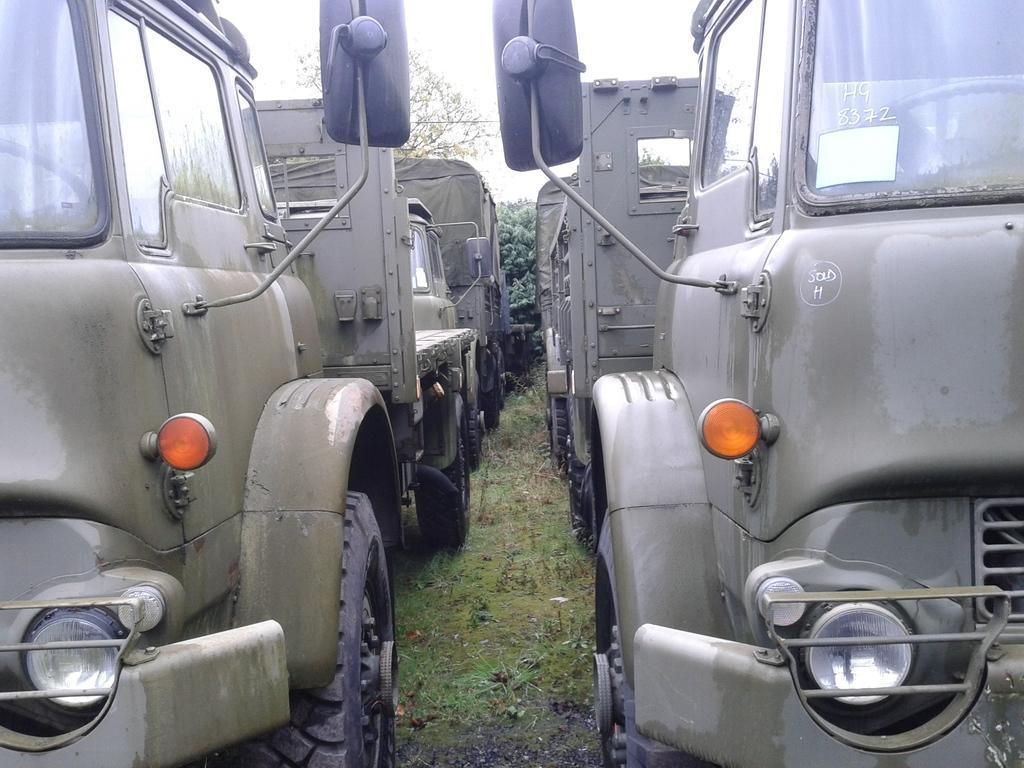How would you summarize this image in a sentence or two? In this image we can see some vehicles, grass and other objects. In the background of the image there are trees and the sky. 